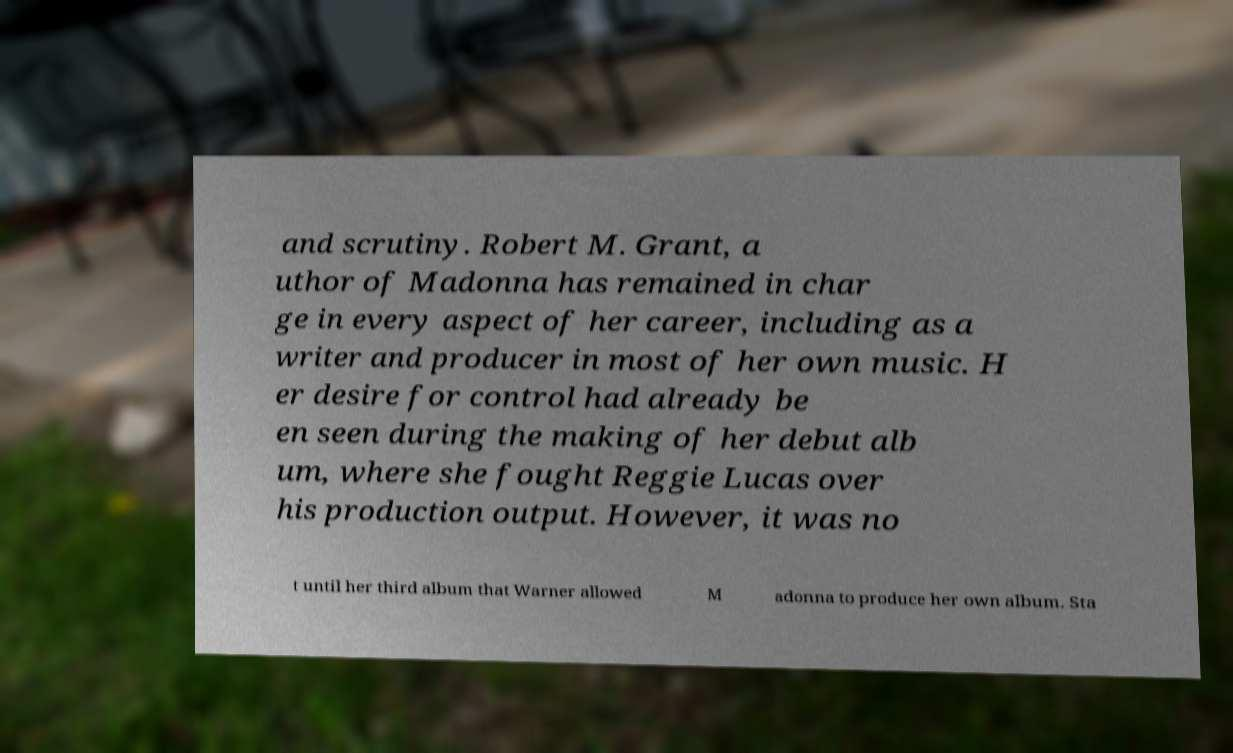Can you read and provide the text displayed in the image?This photo seems to have some interesting text. Can you extract and type it out for me? and scrutiny. Robert M. Grant, a uthor of Madonna has remained in char ge in every aspect of her career, including as a writer and producer in most of her own music. H er desire for control had already be en seen during the making of her debut alb um, where she fought Reggie Lucas over his production output. However, it was no t until her third album that Warner allowed M adonna to produce her own album. Sta 